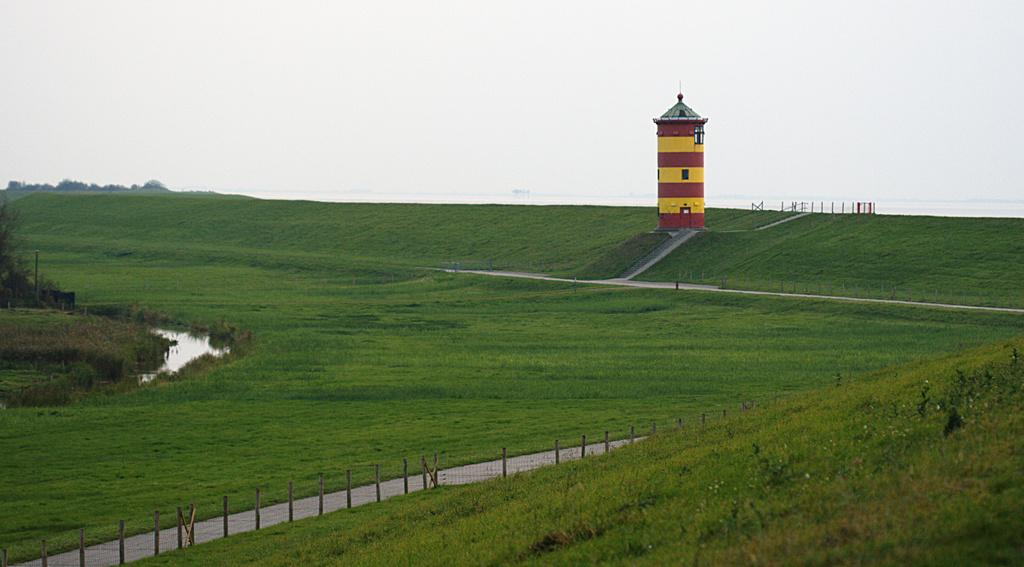What is the main structure in the image? There is a lighthouse in the image. What type of terrain is visible at the bottom of the image? There is grass at the bottom of the image. What type of pathway can be seen in the image? There is a road in the image. What type of barrier is present in the image? There is fencing in the image. What can be seen in the distance in the image? The sky is visible in the background of the image. What type of brass instrument is being played in the image? There is no brass instrument present in the image; it features a lighthouse, grass, road, fencing, and sky. 